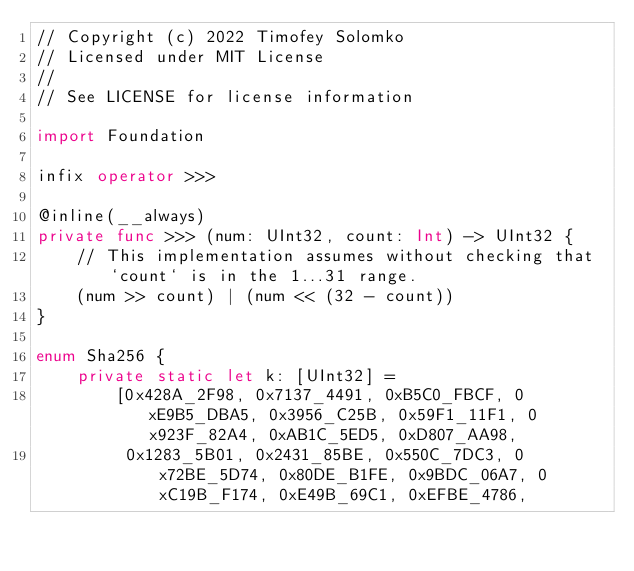Convert code to text. <code><loc_0><loc_0><loc_500><loc_500><_Swift_>// Copyright (c) 2022 Timofey Solomko
// Licensed under MIT License
//
// See LICENSE for license information

import Foundation

infix operator >>>

@inline(__always)
private func >>> (num: UInt32, count: Int) -> UInt32 {
    // This implementation assumes without checking that `count` is in the 1...31 range.
    (num >> count) | (num << (32 - count))
}

enum Sha256 {
    private static let k: [UInt32] =
        [0x428A_2F98, 0x7137_4491, 0xB5C0_FBCF, 0xE9B5_DBA5, 0x3956_C25B, 0x59F1_11F1, 0x923F_82A4, 0xAB1C_5ED5, 0xD807_AA98,
         0x1283_5B01, 0x2431_85BE, 0x550C_7DC3, 0x72BE_5D74, 0x80DE_B1FE, 0x9BDC_06A7, 0xC19B_F174, 0xE49B_69C1, 0xEFBE_4786,</code> 